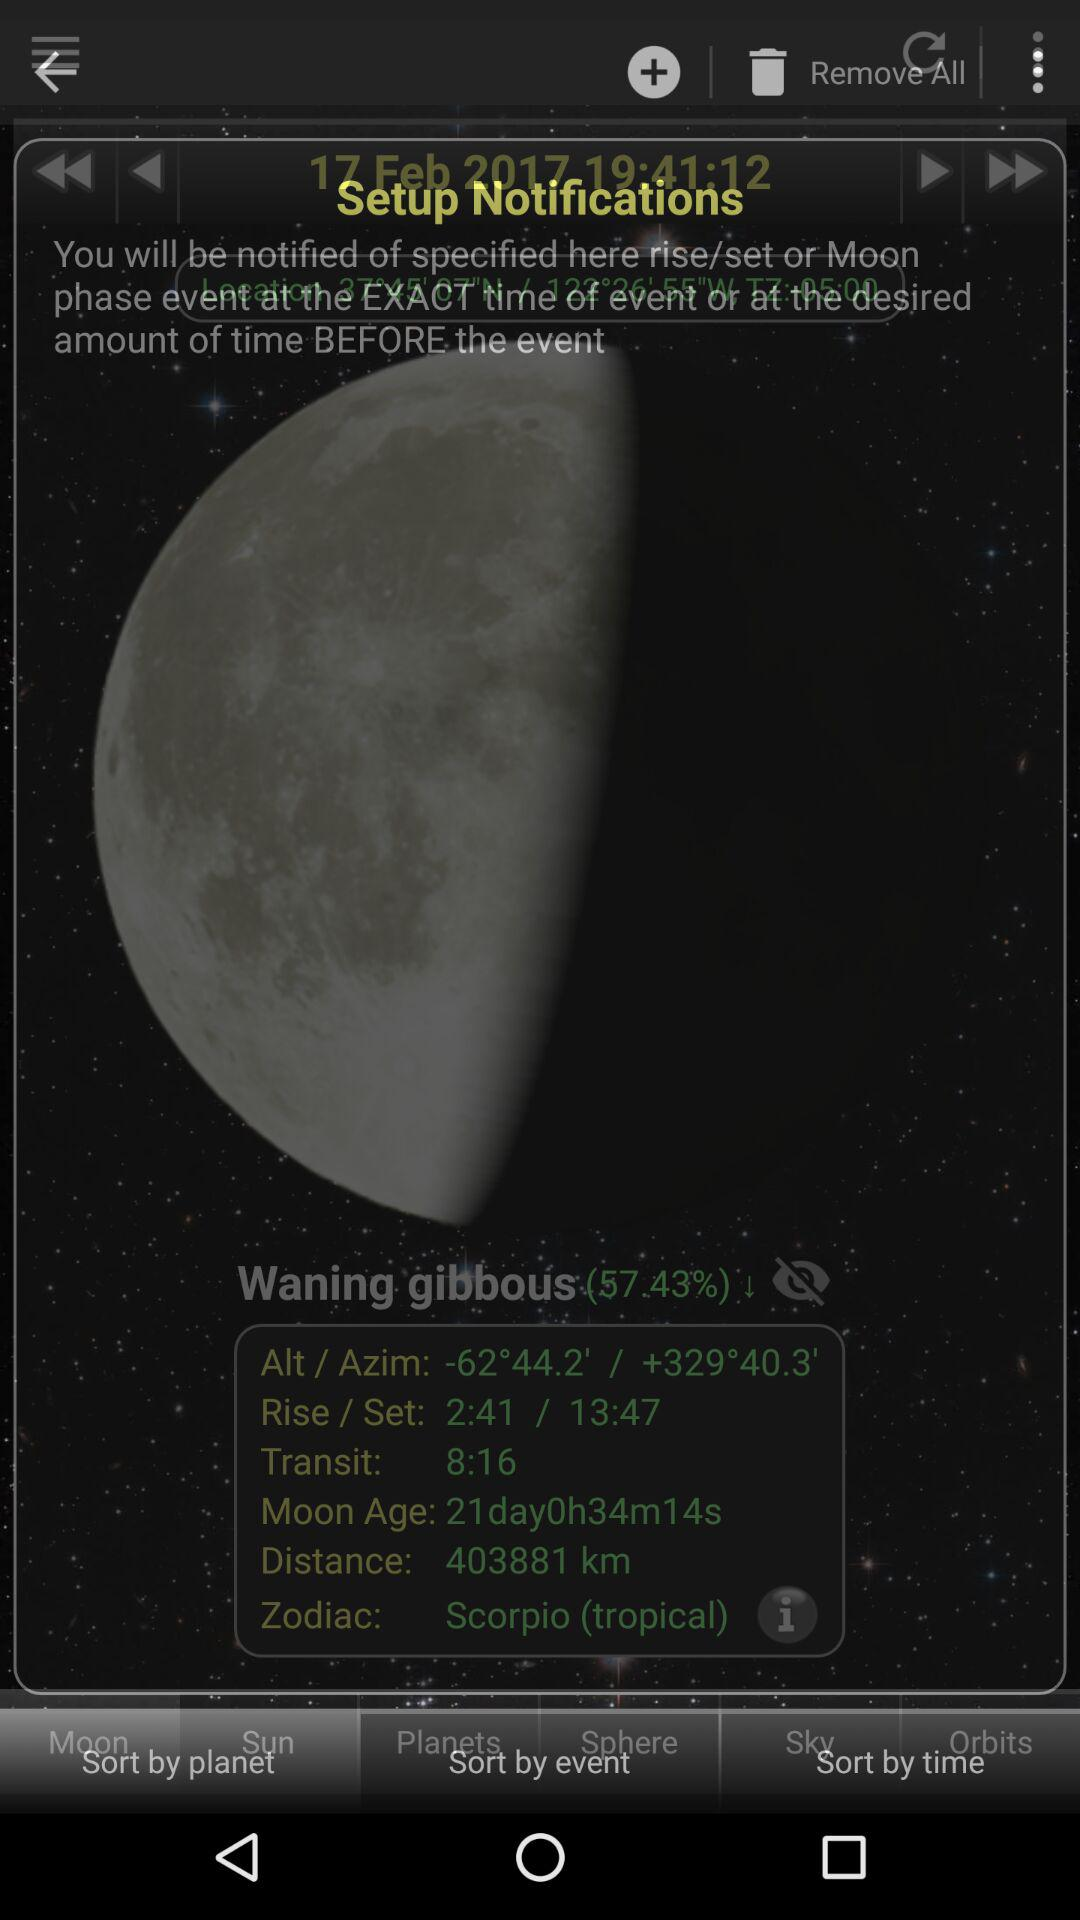What is the distance to the moon in kilometers?
Answer the question using a single word or phrase. 403881 km 